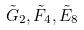<formula> <loc_0><loc_0><loc_500><loc_500>\tilde { G } _ { 2 } , \tilde { F } _ { 4 } , \tilde { E } _ { 8 }</formula> 